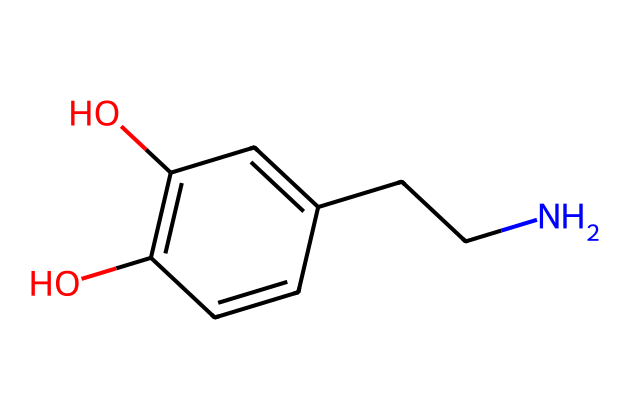What is the molecular formula of this compound? By counting the number of each type of atom in the provided SMILES representation, we can determine the molecular formula. The breakdown shows 8 carbons (C), 11 hydrogens (H), 1 nitrogen (N), and 3 oxygens (O). Therefore, the molecular formula is C8H11N3O3.
Answer: C8H11N3O3 How many hydroxyl (OH) groups are present in this molecule? In the SMILES representation, we can see "O" atoms directly attached to carbon atoms in the structure. By identifying these groups, we find there are two -OH (hydroxyl) functional groups within the structure.
Answer: 2 What type of functional groups are present in dopamine? The structure reveals the presence of both hydroxyl (-OH) groups and an amine (-NH) group. The two -OH indicate phenolic characteristics, while the -NH shows the amino component. Together, these define its biological activity.
Answer: Hydroxyl and amine How many rings does the molecular structure contain? The SMILES notation suggests a cyclic structure through "C1" which indicates a ring formation starting from that carbon, and continuing through the alternating double bonds until returning to the initial carbon. Thus, this structure contains one ring.
Answer: 1 Is dopamine classified as a saturated or unsaturated compound? Analyzing the SMILES representation, we see the presence of double bonds within the cyclic structure (C=C). The existence of these double bonds indicates that the compound is unsaturated since it is not fully surrounded by hydrogen atoms.
Answer: Unsaturated What is the primary distinguishing feature of an aliphatic compound like dopamine? Aliphatic compounds are characterized by their open chain structure without aromatic rings. In this case, though dopamine contains a cyclic part, they can also exhibit aliphatic properties due to the straight-chain attachments off the ring. Therefore, it has both aliphatic and aromatic features.
Answer: Aliphatic and aromatic features 